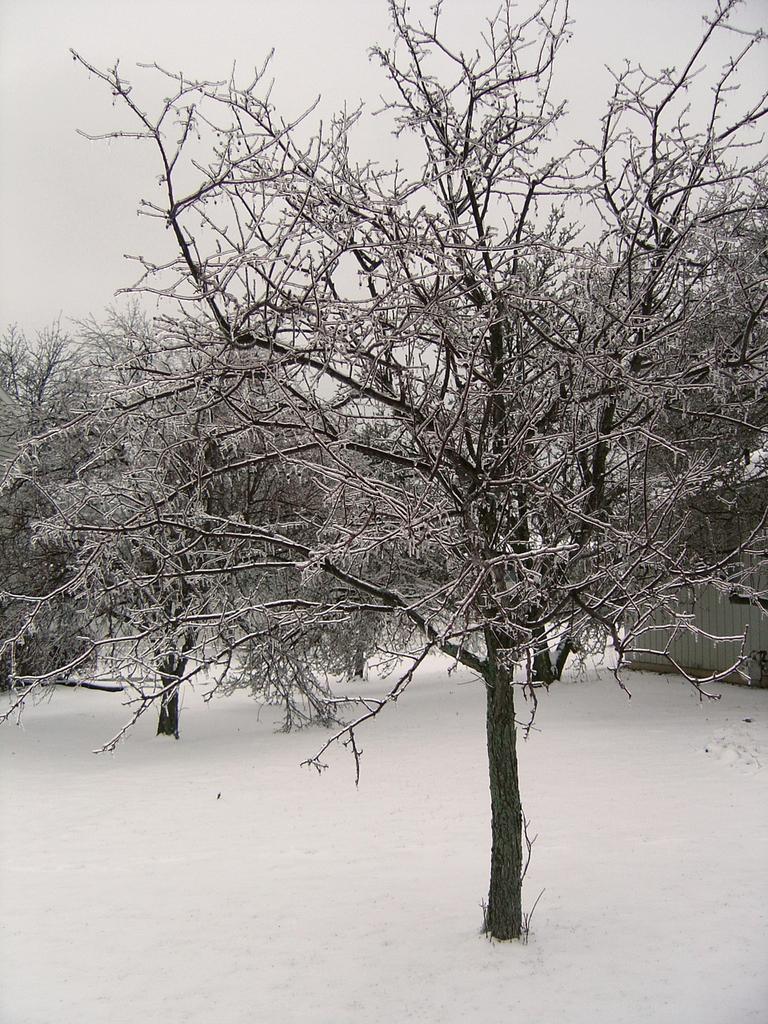How would you summarize this image in a sentence or two? In this image I can see dried trees and snow and the image is in black and white. 